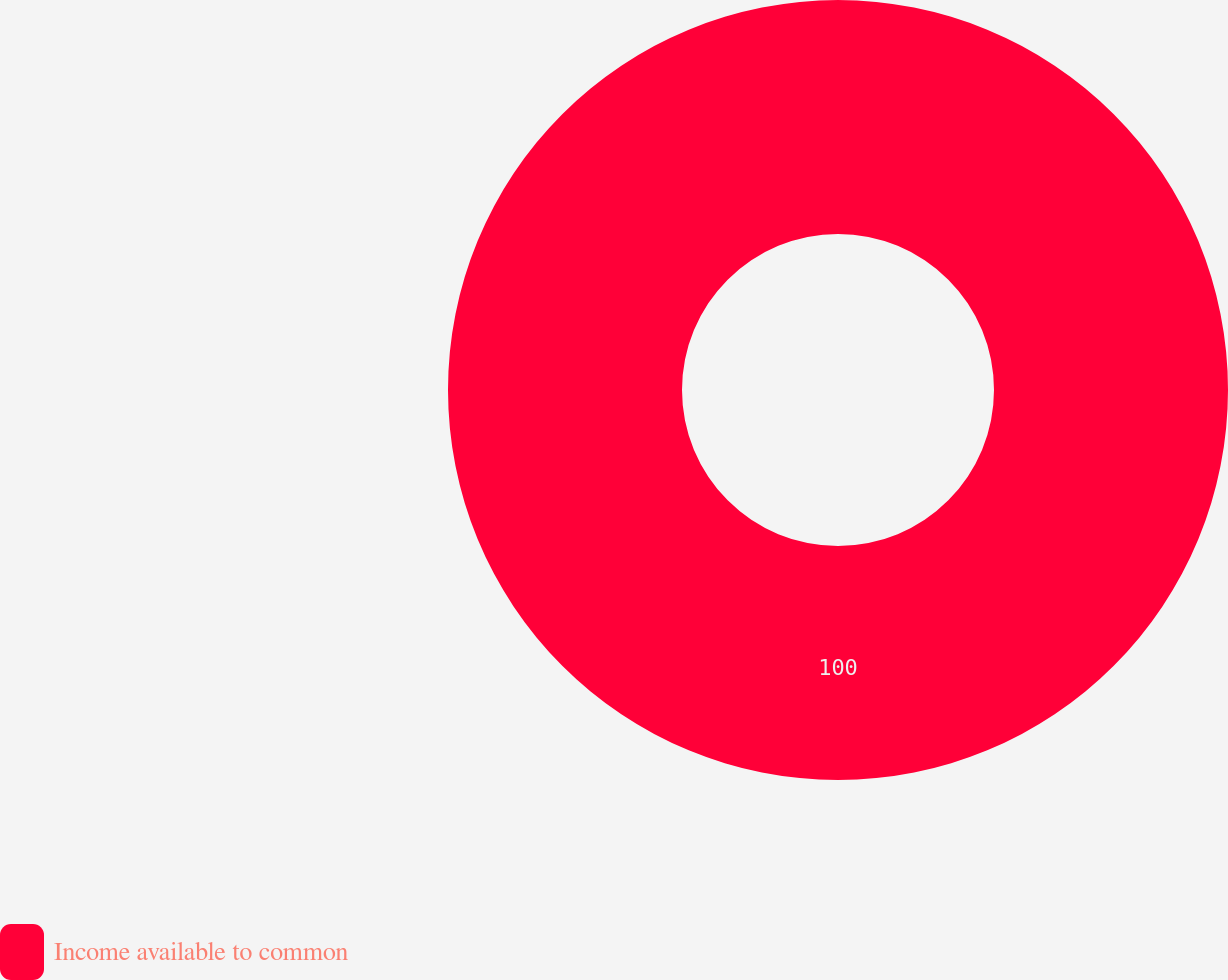<chart> <loc_0><loc_0><loc_500><loc_500><pie_chart><fcel>Income available to common<nl><fcel>100.0%<nl></chart> 